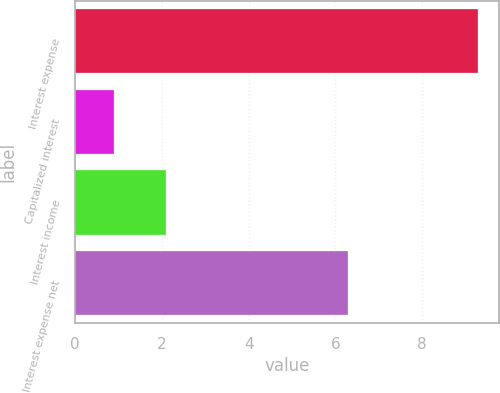<chart> <loc_0><loc_0><loc_500><loc_500><bar_chart><fcel>Interest expense<fcel>Capitalized interest<fcel>Interest income<fcel>Interest expense net<nl><fcel>9.3<fcel>0.9<fcel>2.1<fcel>6.3<nl></chart> 